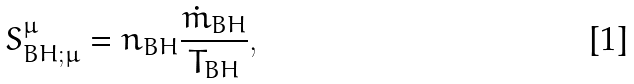Convert formula to latex. <formula><loc_0><loc_0><loc_500><loc_500>S _ { B H ; \mu } ^ { \mu } = n _ { B H } \frac { \dot { m } _ { B H } } { T _ { B H } } ,</formula> 